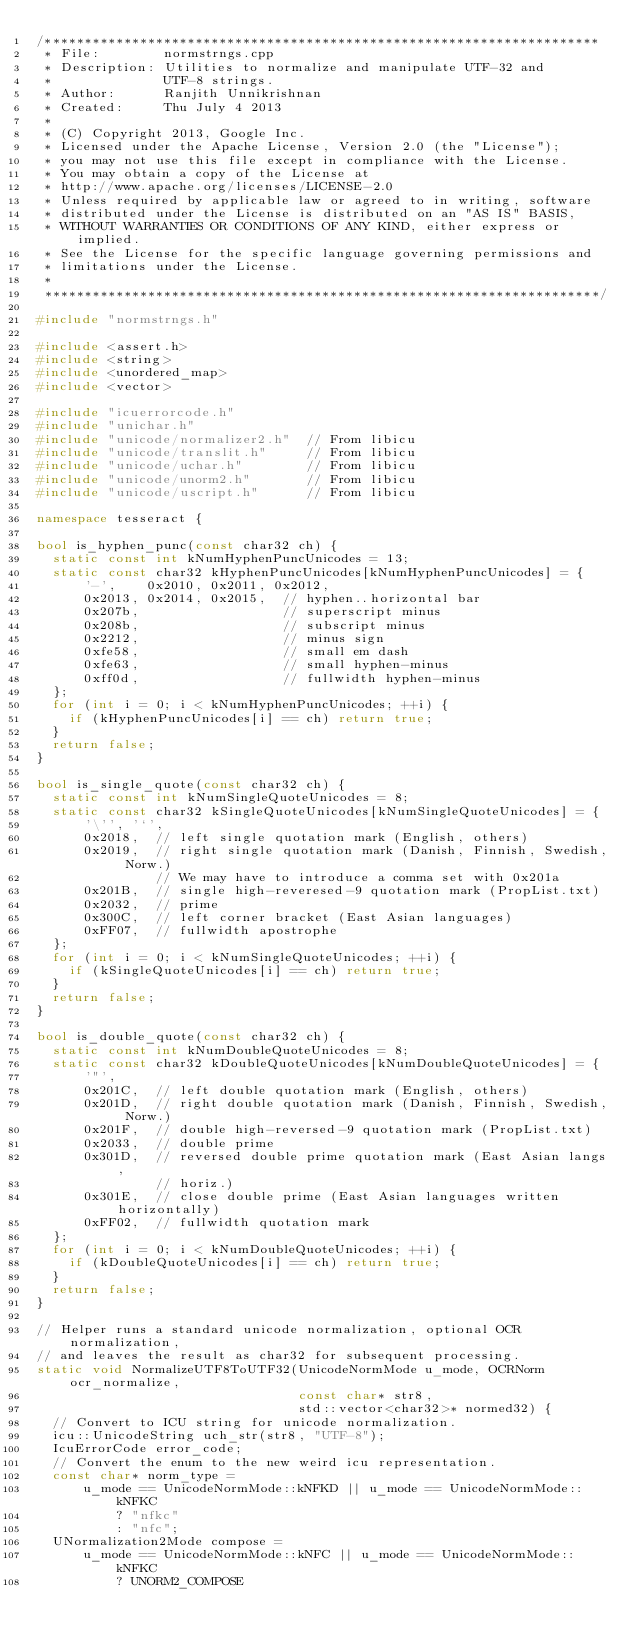<code> <loc_0><loc_0><loc_500><loc_500><_C++_>/**********************************************************************
 * File:        normstrngs.cpp
 * Description: Utilities to normalize and manipulate UTF-32 and
 *              UTF-8 strings.
 * Author:      Ranjith Unnikrishnan
 * Created:     Thu July 4 2013
 *
 * (C) Copyright 2013, Google Inc.
 * Licensed under the Apache License, Version 2.0 (the "License");
 * you may not use this file except in compliance with the License.
 * You may obtain a copy of the License at
 * http://www.apache.org/licenses/LICENSE-2.0
 * Unless required by applicable law or agreed to in writing, software
 * distributed under the License is distributed on an "AS IS" BASIS,
 * WITHOUT WARRANTIES OR CONDITIONS OF ANY KIND, either express or implied.
 * See the License for the specific language governing permissions and
 * limitations under the License.
 *
 **********************************************************************/

#include "normstrngs.h"

#include <assert.h>
#include <string>
#include <unordered_map>
#include <vector>

#include "icuerrorcode.h"
#include "unichar.h"
#include "unicode/normalizer2.h"  // From libicu
#include "unicode/translit.h"     // From libicu
#include "unicode/uchar.h"        // From libicu
#include "unicode/unorm2.h"       // From libicu
#include "unicode/uscript.h"      // From libicu

namespace tesseract {

bool is_hyphen_punc(const char32 ch) {
  static const int kNumHyphenPuncUnicodes = 13;
  static const char32 kHyphenPuncUnicodes[kNumHyphenPuncUnicodes] = {
      '-',    0x2010, 0x2011, 0x2012,
      0x2013, 0x2014, 0x2015,  // hyphen..horizontal bar
      0x207b,                  // superscript minus
      0x208b,                  // subscript minus
      0x2212,                  // minus sign
      0xfe58,                  // small em dash
      0xfe63,                  // small hyphen-minus
      0xff0d,                  // fullwidth hyphen-minus
  };
  for (int i = 0; i < kNumHyphenPuncUnicodes; ++i) {
    if (kHyphenPuncUnicodes[i] == ch) return true;
  }
  return false;
}

bool is_single_quote(const char32 ch) {
  static const int kNumSingleQuoteUnicodes = 8;
  static const char32 kSingleQuoteUnicodes[kNumSingleQuoteUnicodes] = {
      '\'', '`',
      0x2018,  // left single quotation mark (English, others)
      0x2019,  // right single quotation mark (Danish, Finnish, Swedish, Norw.)
               // We may have to introduce a comma set with 0x201a
      0x201B,  // single high-reveresed-9 quotation mark (PropList.txt)
      0x2032,  // prime
      0x300C,  // left corner bracket (East Asian languages)
      0xFF07,  // fullwidth apostrophe
  };
  for (int i = 0; i < kNumSingleQuoteUnicodes; ++i) {
    if (kSingleQuoteUnicodes[i] == ch) return true;
  }
  return false;
}

bool is_double_quote(const char32 ch) {
  static const int kNumDoubleQuoteUnicodes = 8;
  static const char32 kDoubleQuoteUnicodes[kNumDoubleQuoteUnicodes] = {
      '"',
      0x201C,  // left double quotation mark (English, others)
      0x201D,  // right double quotation mark (Danish, Finnish, Swedish, Norw.)
      0x201F,  // double high-reversed-9 quotation mark (PropList.txt)
      0x2033,  // double prime
      0x301D,  // reversed double prime quotation mark (East Asian langs,
               // horiz.)
      0x301E,  // close double prime (East Asian languages written horizontally)
      0xFF02,  // fullwidth quotation mark
  };
  for (int i = 0; i < kNumDoubleQuoteUnicodes; ++i) {
    if (kDoubleQuoteUnicodes[i] == ch) return true;
  }
  return false;
}

// Helper runs a standard unicode normalization, optional OCR normalization,
// and leaves the result as char32 for subsequent processing.
static void NormalizeUTF8ToUTF32(UnicodeNormMode u_mode, OCRNorm ocr_normalize,
                                 const char* str8,
                                 std::vector<char32>* normed32) {
  // Convert to ICU string for unicode normalization.
  icu::UnicodeString uch_str(str8, "UTF-8");
  IcuErrorCode error_code;
  // Convert the enum to the new weird icu representation.
  const char* norm_type =
      u_mode == UnicodeNormMode::kNFKD || u_mode == UnicodeNormMode::kNFKC
          ? "nfkc"
          : "nfc";
  UNormalization2Mode compose =
      u_mode == UnicodeNormMode::kNFC || u_mode == UnicodeNormMode::kNFKC
          ? UNORM2_COMPOSE</code> 